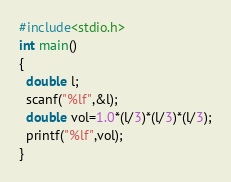Convert code to text. <code><loc_0><loc_0><loc_500><loc_500><_C_>#include<stdio.h>
int main()
{
  double l;
  scanf("%lf",&l);
  double vol=1.0*(l/3)*(l/3)*(l/3);
  printf("%lf",vol);
}</code> 